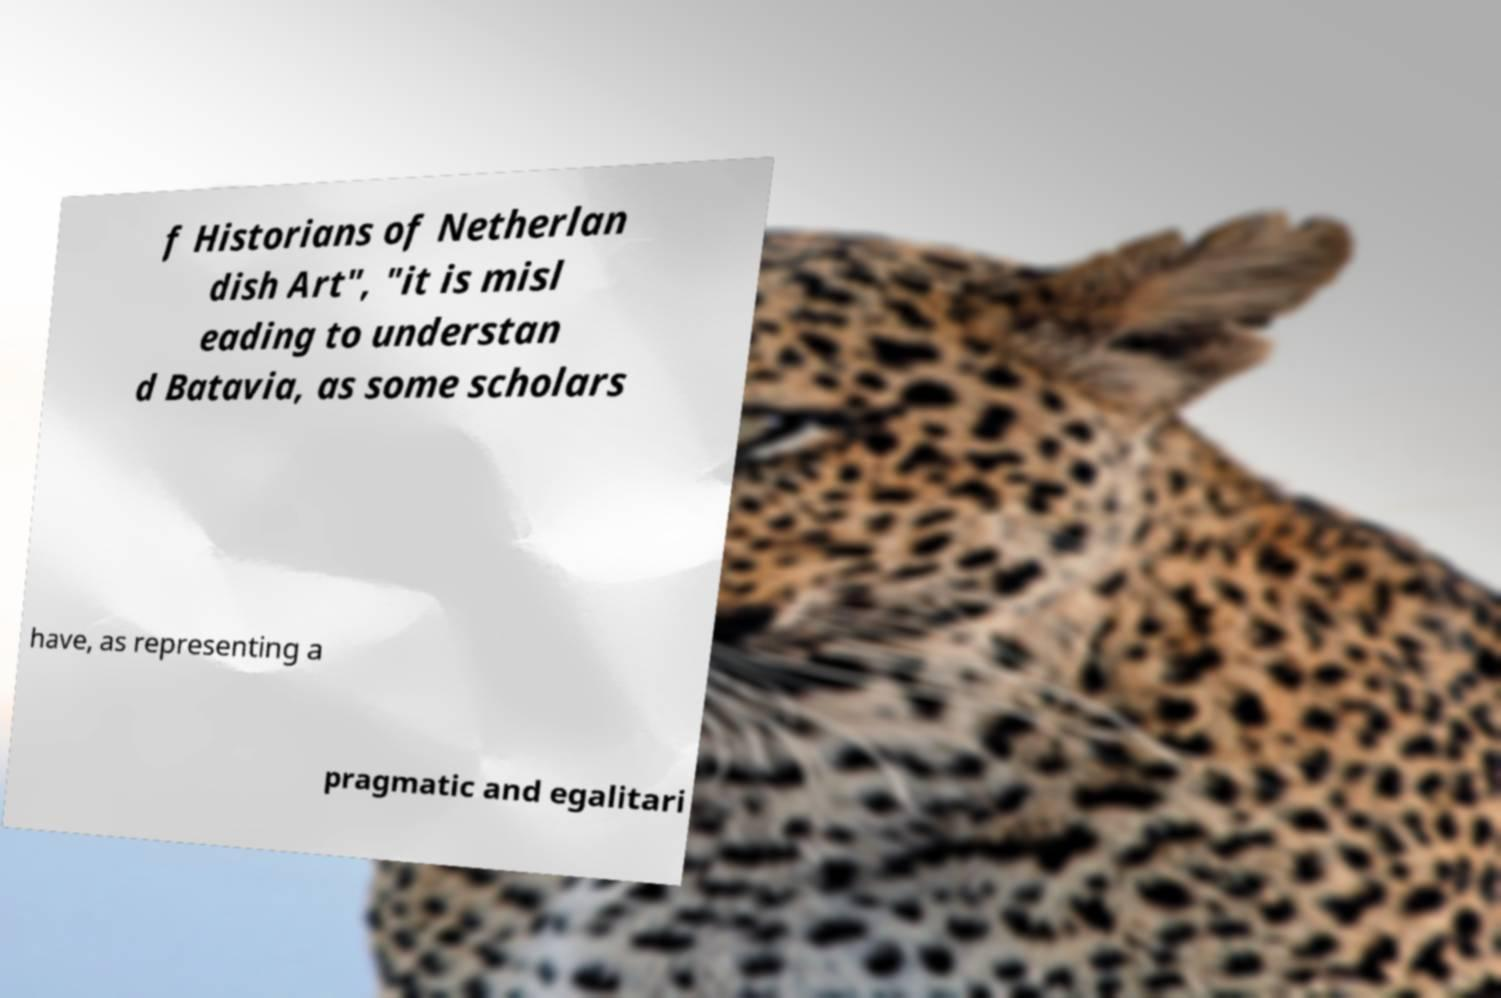Can you read and provide the text displayed in the image?This photo seems to have some interesting text. Can you extract and type it out for me? f Historians of Netherlan dish Art", "it is misl eading to understan d Batavia, as some scholars have, as representing a pragmatic and egalitari 